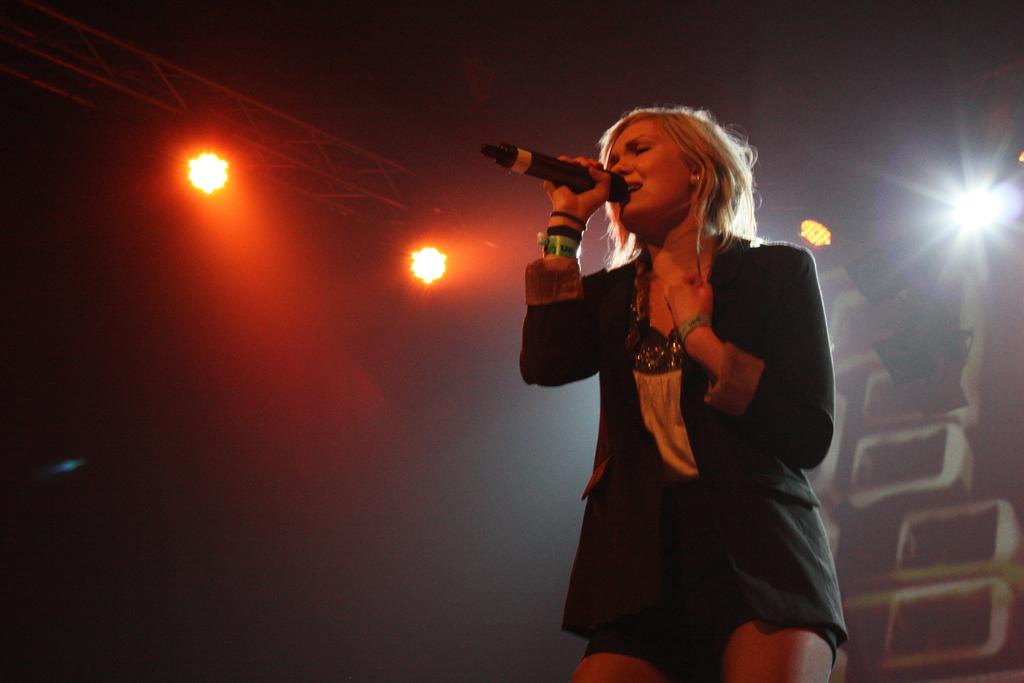What is the main subject in the foreground of the picture? There is a woman in the foreground of the picture. What is the woman holding in the image? The woman is holding a mic. What is the woman doing in the image? The woman is singing. What can be seen on the left side of the image? There are focus lights on the left side of the image. What is present on the right side of the image? There are focus lights and other objects on the right side of the image. Can you see the seashore in the background of the image? There is no seashore visible in the image. How many women are present in the image? There is only one woman present in the image. 